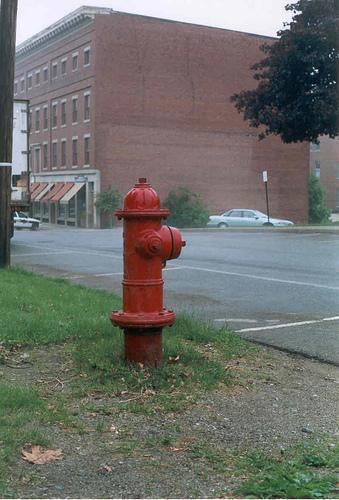How many cars are pictured?
Give a very brief answer. 2. 